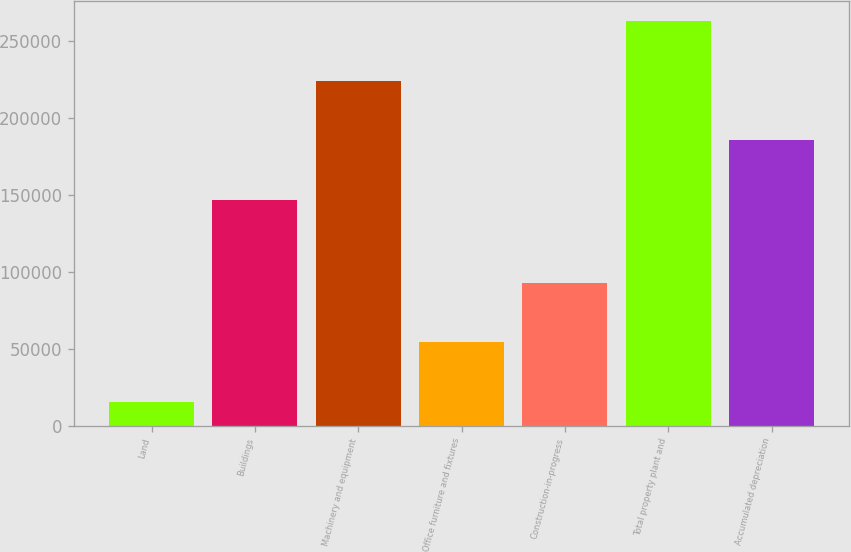Convert chart to OTSL. <chart><loc_0><loc_0><loc_500><loc_500><bar_chart><fcel>Land<fcel>Buildings<fcel>Machinery and equipment<fcel>Office furniture and fixtures<fcel>Construction-in-progress<fcel>Total property plant and<fcel>Accumulated depreciation<nl><fcel>15448<fcel>146730<fcel>224386<fcel>54276<fcel>93104<fcel>263214<fcel>185558<nl></chart> 